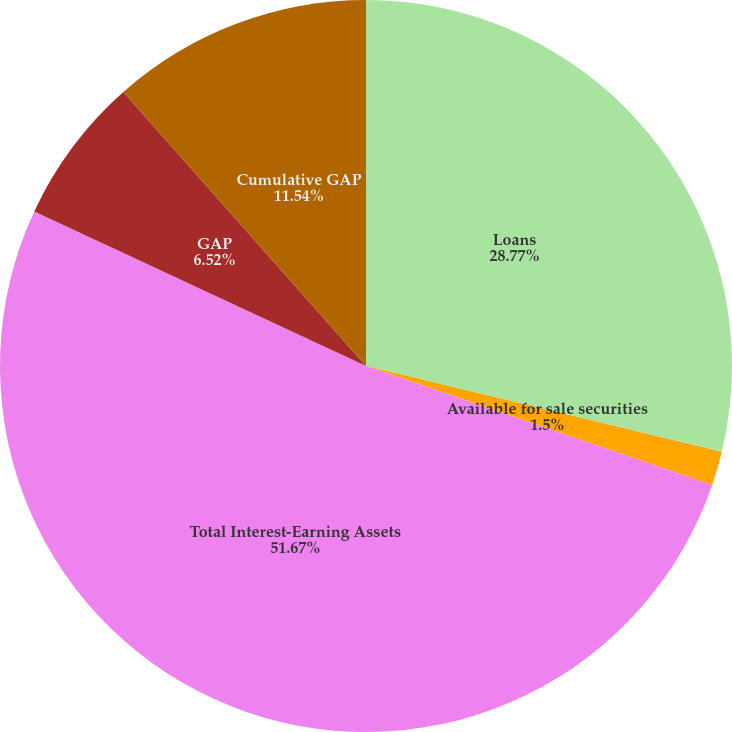Convert chart. <chart><loc_0><loc_0><loc_500><loc_500><pie_chart><fcel>Loans<fcel>Available for sale securities<fcel>Total Interest-Earning Assets<fcel>GAP<fcel>Cumulative GAP<nl><fcel>28.77%<fcel>1.5%<fcel>51.68%<fcel>6.52%<fcel>11.54%<nl></chart> 